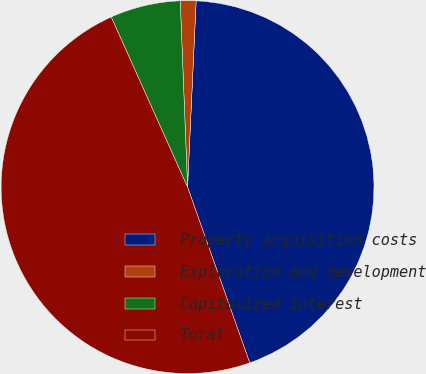Convert chart to OTSL. <chart><loc_0><loc_0><loc_500><loc_500><pie_chart><fcel>Property acquisition costs<fcel>Exploration and development<fcel>Capitalized interest<fcel>Total<nl><fcel>43.85%<fcel>1.36%<fcel>6.09%<fcel>48.7%<nl></chart> 